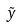Convert formula to latex. <formula><loc_0><loc_0><loc_500><loc_500>\tilde { y }</formula> 